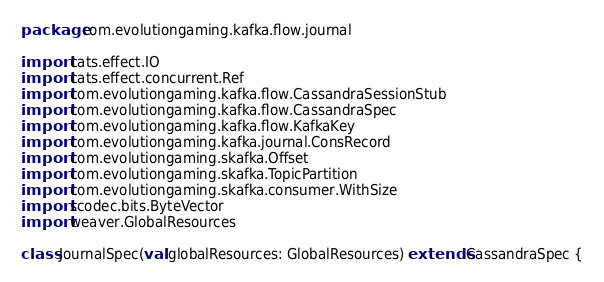Convert code to text. <code><loc_0><loc_0><loc_500><loc_500><_Scala_>package com.evolutiongaming.kafka.flow.journal

import cats.effect.IO
import cats.effect.concurrent.Ref
import com.evolutiongaming.kafka.flow.CassandraSessionStub
import com.evolutiongaming.kafka.flow.CassandraSpec
import com.evolutiongaming.kafka.flow.KafkaKey
import com.evolutiongaming.kafka.journal.ConsRecord
import com.evolutiongaming.skafka.Offset
import com.evolutiongaming.skafka.TopicPartition
import com.evolutiongaming.skafka.consumer.WithSize
import scodec.bits.ByteVector
import weaver.GlobalResources

class JournalSpec(val globalResources: GlobalResources) extends CassandraSpec {
</code> 